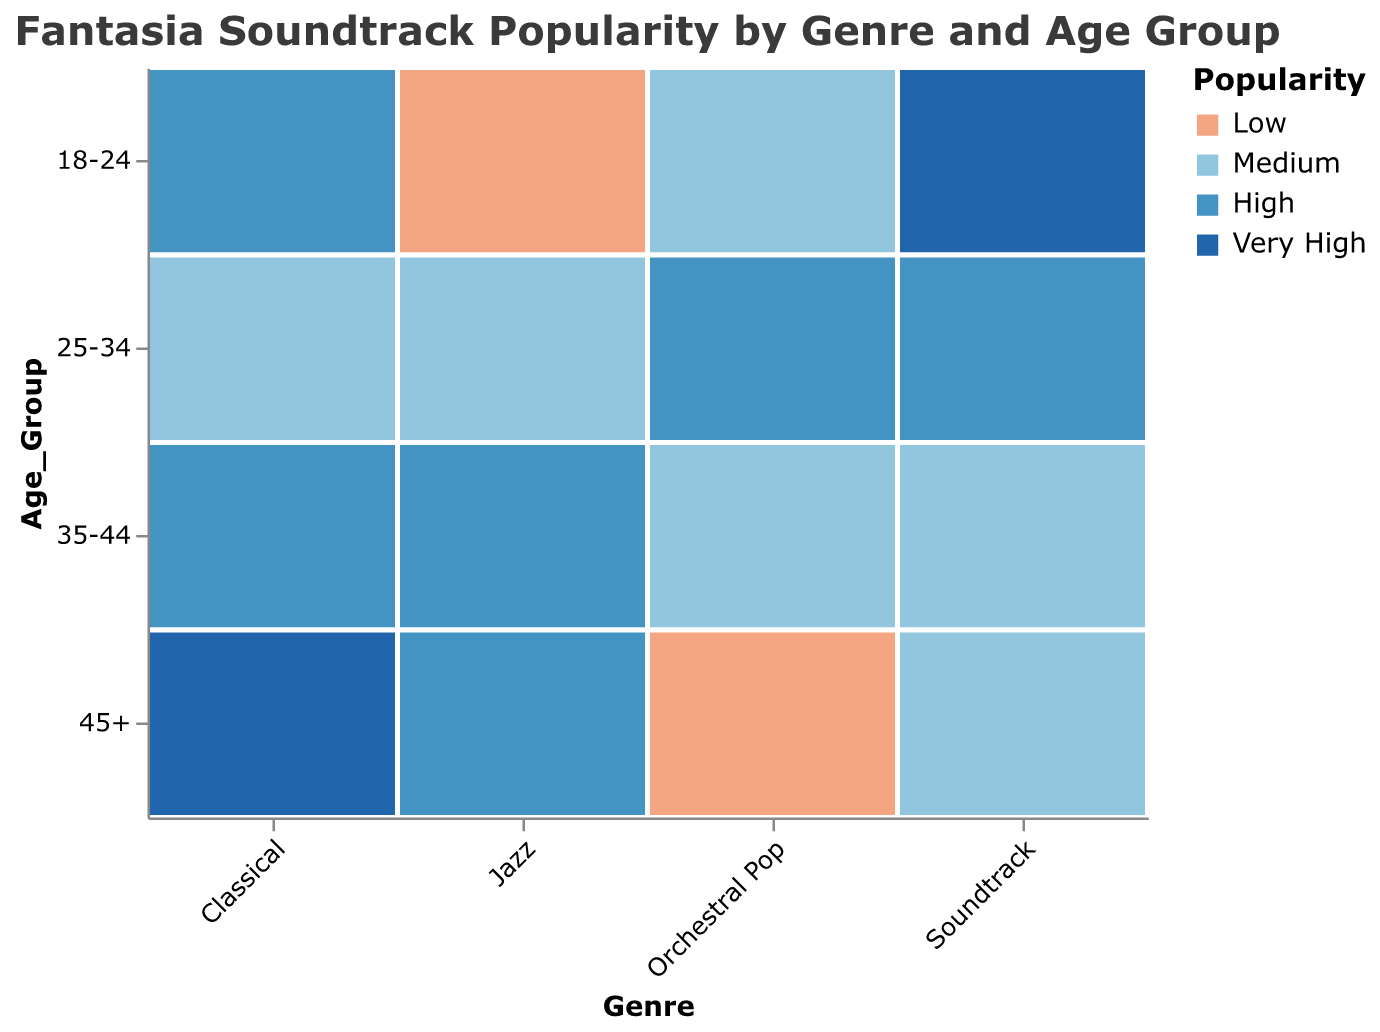What's the most popular genre among listeners aged 18-24? By looking at the plot's color for Age_Group 18-24, we notice the rectangle labeled "Very High" popularity is for the Soundtrack genre.
Answer: Soundtrack Which age group has the lowest popularity for Jazz? The plot shows "Low" popularity for Jazz among the 18-24 age group. The color for this combination indicates the lowest popularity.
Answer: 18-24 Compare the popularity of Classical music among listeners aged 35-44 and those aged 45+. Which group finds it more popular? For Classical music, the 35-44 age group shows "High" popularity, while the 45+ age group indicates "Very High" popularity. Therefore, Classical is more popular among the 45+ group.
Answer: 45+ What's the difference in popularity for the Soundtrack genre between the 18-24 and 25-34 age groups? The 18-24 age group has "Very High" popularity for Soundtrack, and the 25-34 age group has "High" popularity. The difference is one level down the popularity scale from "Very High" to "High".
Answer: One level down Which age group has the widest range of popularity scores for Orchestral Pop? For Orchestral Pop, the popularity ranges from "Medium" in 18-24, "Low" in 45+, to "High" in 25-34. This indicates a wide range of popularity scores within these three age groups.
Answer: 25-34 How does the popularity of Jazz among the 45+ age group compare to that of the 25-34 age group? The plot shows that both age groups (45+ and 25-34) have "High" popularity for Jazz. Therefore, they have equal popularity levels.
Answer: Equal What is the overall trend in popularity for the Classical genre across increasing age groups? The popularity for Classical increases from "High" (18-24), to "Medium" (25-34), back to "High" (35-44), and concludes with "Very High" (45+). The general trend indicates an increase as the age group rises.
Answer: Increasing If you sum the popularity levels (assigning Low=1, Medium=2, High=3, Very High=4) for the Orchestral Pop genre, what is the total score? Assigning the values, the scores are: 18-24 (Medium=2), 25-34 (High=3), 35-44 (Medium=2), 45+ (Low=1). The total score sums up to 2 + 3 + 2 + 1 = 8.
Answer: 8 How many age groups show a "Very High" popularity for any genre? The "Very High" popularity color is seen for Classical (45+) and Soundtrack (18-24). Therefore, two age groups show a "Very High" popularity.
Answer: Two 